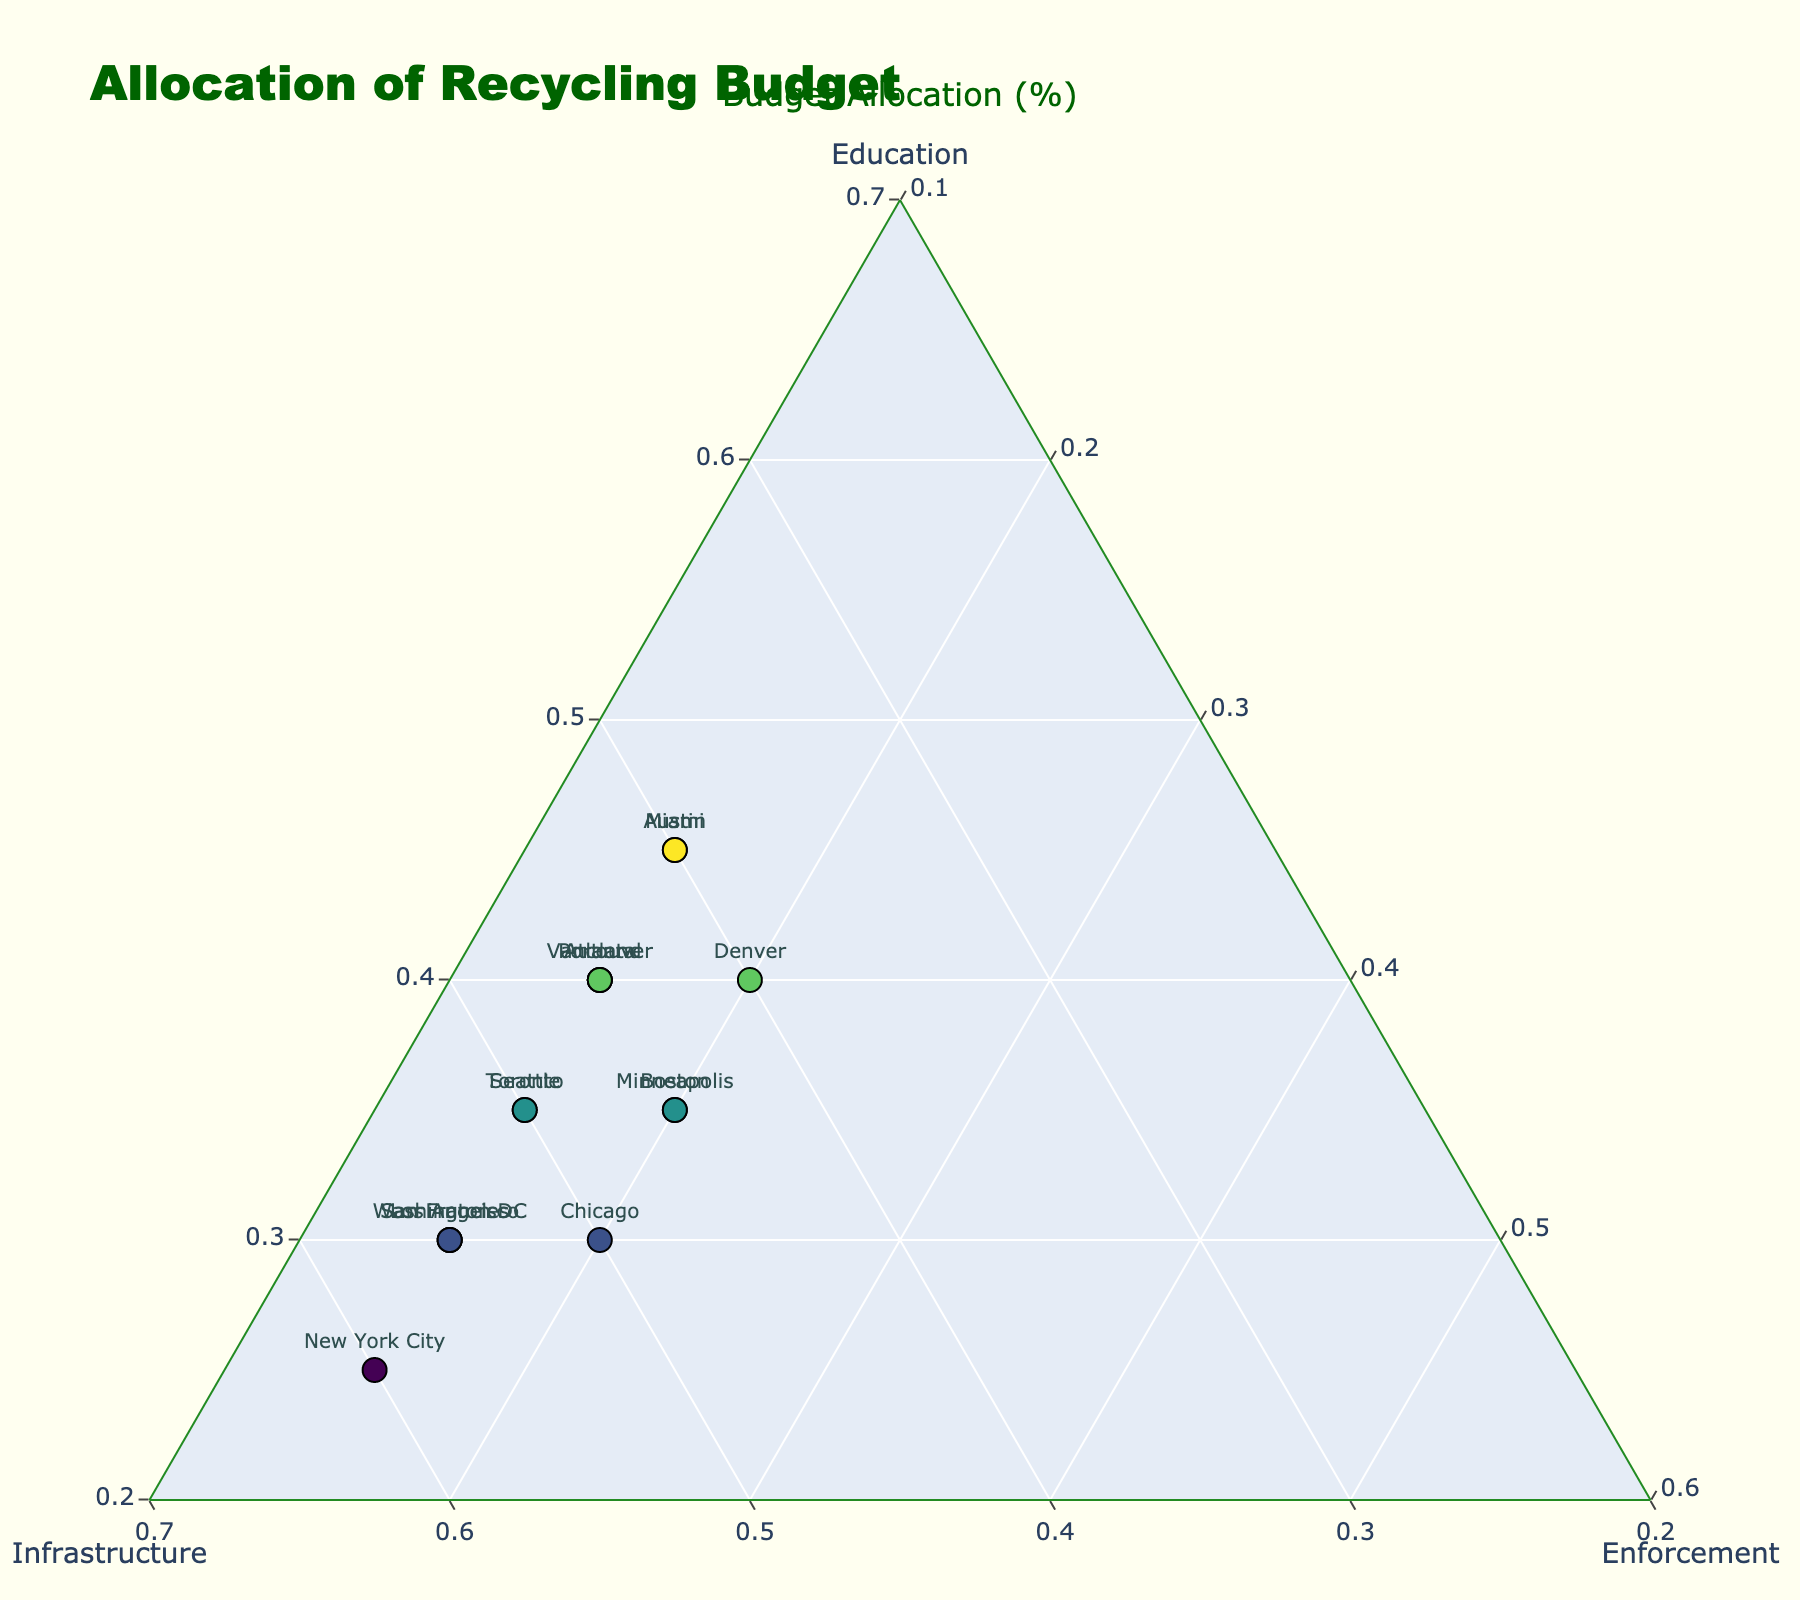Which city has the highest allocation for infrastructure? Identify the cities with the highest percentage values in the infrastructure allocation. "New York City" has 60% allocated to infrastructure, which is the highest among all cities.
Answer: New York City What is the title of the plot? Read the title text at the top of the plot.
Answer: Allocation of Recycling Budget How many cities allocate exactly 15% to enforcement? Identify the cities whose enforcement allocation is 15%. There are 10 cities: Portland, Seattle, San Francisco, Austin, Washington DC, Vancouver, Toronto, New York City, Los Angeles, and Atlanta, all allocating 15% to enforcement.
Answer: 10 Which city has the highest allocation for education? Identify the cities with the highest percentage values for the education allocation. Both "Austin" and "Miami" allocate 45% to education, which is the highest.
Answer: Austin and Miami What is the minimum value set for the 'Education' axis? Read the label or axis limit directly from the axis settings on the plot. The minimum value on the 'Education' axis is 20%.
Answer: 20% Which cities have equal allocations for infrastructure and enforcement? Identify cities where the values for 'Infrastructure' and 'Enforcement' allocations are the same. No city in the provided dataset has equal allocations for infrastructure and enforcement.
Answer: None What is the distribution of budget allocation for "Denver"? Find the data point for "Denver" and read off the normalized values for Education, Infrastructure, and Enforcement. "Denver" allocates 40% to education, 40% to infrastructure, and 20% to enforcement.
Answer: Education: 40%, Infrastructure: 40%, Enforcement: 20% How many cities allocate more than 25% to enforcement? Identify cities where the enforcement allocation percentage is greater than 25%. No city has an enforcement allocation above 25%.
Answer: 0 What is the median percentage allocation for education among the cities? First, order the cities' education allocations: 25, 30, 30, 30, 35, 35, 35, 35, 40, 40, 40, 40, 45, 45, 45. Since there are 15 data points, the median is the 8th value in the ordered list, which is 35%.
Answer: 35% Which cities' budget allocations form a boundary around the highest enforcement percentage? Identify the outermost points for enforcement allocation, which is 20%. The cities "Minneapolis," "Denver," "Chicago," and "Boston" have the highest enforcement percentage forming the boundary.
Answer: Minneapolis, Denver, Chicago, and Boston 